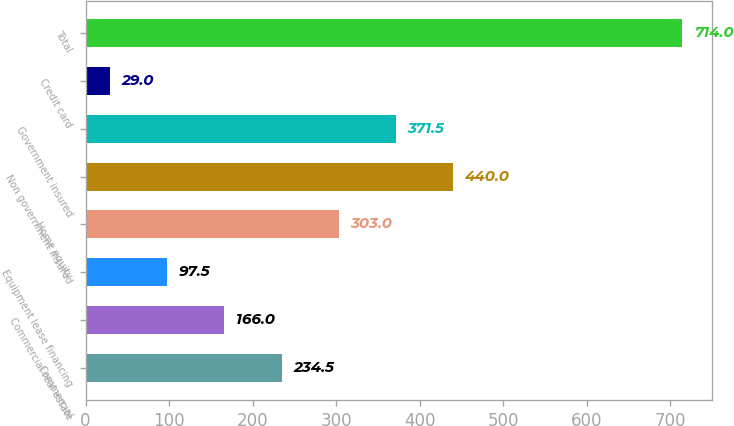<chart> <loc_0><loc_0><loc_500><loc_500><bar_chart><fcel>Commercial<fcel>Commercial real estate<fcel>Equipment lease financing<fcel>Home equity<fcel>Non government insured<fcel>Government insured<fcel>Credit card<fcel>Total<nl><fcel>234.5<fcel>166<fcel>97.5<fcel>303<fcel>440<fcel>371.5<fcel>29<fcel>714<nl></chart> 